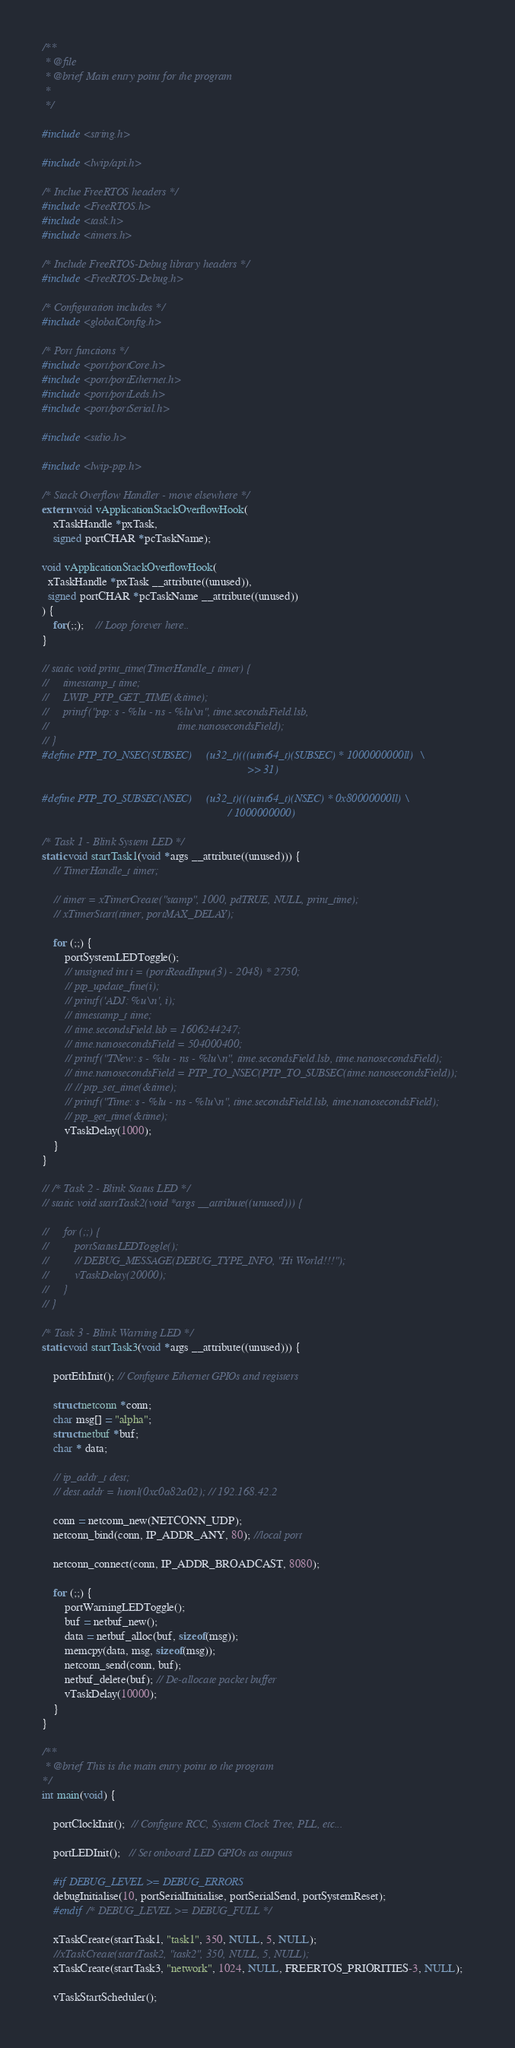<code> <loc_0><loc_0><loc_500><loc_500><_C_>/**
 * @file
 * @brief Main entry point for the program
 *
 */

#include <string.h>

#include <lwip/api.h>

/* Inclue FreeRTOS headers */
#include <FreeRTOS.h>
#include <task.h>
#include <timers.h>

/* Include FreeRTOS-Debug library headers */
#include <FreeRTOS-Debug.h>

/* Configuration includes */
#include <globalConfig.h>

/* Port functions */
#include <port/portCore.h>
#include <port/portEthernet.h>
#include <port/portLeds.h>
#include <port/portSerial.h>

#include <stdio.h>

#include <lwip-ptp.h>

/* Stack Overflow Handler - move elsewhere */
extern void vApplicationStackOverflowHook(
    xTaskHandle *pxTask,
    signed portCHAR *pcTaskName);

void vApplicationStackOverflowHook(
  xTaskHandle *pxTask __attribute((unused)),
  signed portCHAR *pcTaskName __attribute((unused))
) {
    for(;;);    // Loop forever here..
}

// static void print_time(TimerHandle_t timer) {
//     timestamp_t time;
//     LWIP_PTP_GET_TIME(&time);
//     printf("ptp: s - %lu - ns - %lu\n", time.secondsField.lsb,
//                                             time.nanosecondsField);
// }
#define PTP_TO_NSEC(SUBSEC)     (u32_t)(((uint64_t)(SUBSEC) * 1000000000ll)  \
                                                                        >> 31)

#define PTP_TO_SUBSEC(NSEC)     (u32_t)(((uint64_t)(NSEC) * 0x80000000ll) \
                                                                 / 1000000000)

/* Task 1 - Blink System LED */
static void startTask1(void *args __attribute((unused))) {
    // TimerHandle_t timer;

    // timer = xTimerCreate("stamp", 1000, pdTRUE, NULL, print_time);
    // xTimerStart(timer, portMAX_DELAY);

    for (;;) {
        portSystemLEDToggle();
        // unsigned int i = (portReadInput(3) - 2048) * 2750;
        // ptp_update_fine(i);
        // printf('ADJ: %u\n', i);
        // timestamp_t time;
        // time.secondsField.lsb = 1606244247;
        // time.nanosecondsField = 504000400;
        // printf("TNew: s - %lu - ns - %lu\n", time.secondsField.lsb, time.nanosecondsField);
        // time.nanosecondsField = PTP_TO_NSEC(PTP_TO_SUBSEC(time.nanosecondsField));
        // // ptp_set_time(&time);
        // printf("Time: s - %lu - ns - %lu\n", time.secondsField.lsb, time.nanosecondsField);
        // ptp_get_time(&time);
        vTaskDelay(1000);
    }
}

// /* Task 2 - Blink Status LED */
// static void startTask2(void *args __attribute((unused))) {

//     for (;;) {
//         portStatusLEDToggle();
//         // DEBUG_MESSAGE(DEBUG_TYPE_INFO, "Hi World!!!");
//         vTaskDelay(20000);
//     }
// }

/* Task 3 - Blink Warning LED */
static void startTask3(void *args __attribute((unused))) {

    portEthInit(); // Configure Ethernet GPIOs and registers

    struct netconn *conn;
    char msg[] = "alpha";
    struct netbuf *buf;
    char * data;

    // ip_addr_t dest;
    // dest.addr = htonl(0xc0a82a02); // 192.168.42.2

    conn = netconn_new(NETCONN_UDP);
    netconn_bind(conn, IP_ADDR_ANY, 80); //local port

    netconn_connect(conn, IP_ADDR_BROADCAST, 8080);

    for (;;) {
        portWarningLEDToggle();
        buf = netbuf_new();
        data = netbuf_alloc(buf, sizeof(msg));
        memcpy(data, msg, sizeof(msg));
        netconn_send(conn, buf);
        netbuf_delete(buf); // De-allocate packet buffer
        vTaskDelay(10000);
    }
}

/**
 * @brief This is the main entry point to the program
*/
int main(void) {

    portClockInit();  // Configure RCC, System Clock Tree, PLL, etc...

    portLEDInit();   // Set onboard LED GPIOs as outputs

    #if DEBUG_LEVEL >= DEBUG_ERRORS
    debugInitialise(10, portSerialInitialise, portSerialSend, portSystemReset);
    #endif /* DEBUG_LEVEL >= DEBUG_FULL */

    xTaskCreate(startTask1, "task1", 350, NULL, 5, NULL);
    //xTaskCreate(startTask2, "task2", 350, NULL, 5, NULL);
    xTaskCreate(startTask3, "network", 1024, NULL, FREERTOS_PRIORITIES-3, NULL);

    vTaskStartScheduler();
</code> 